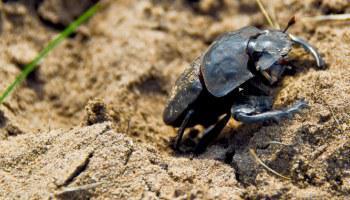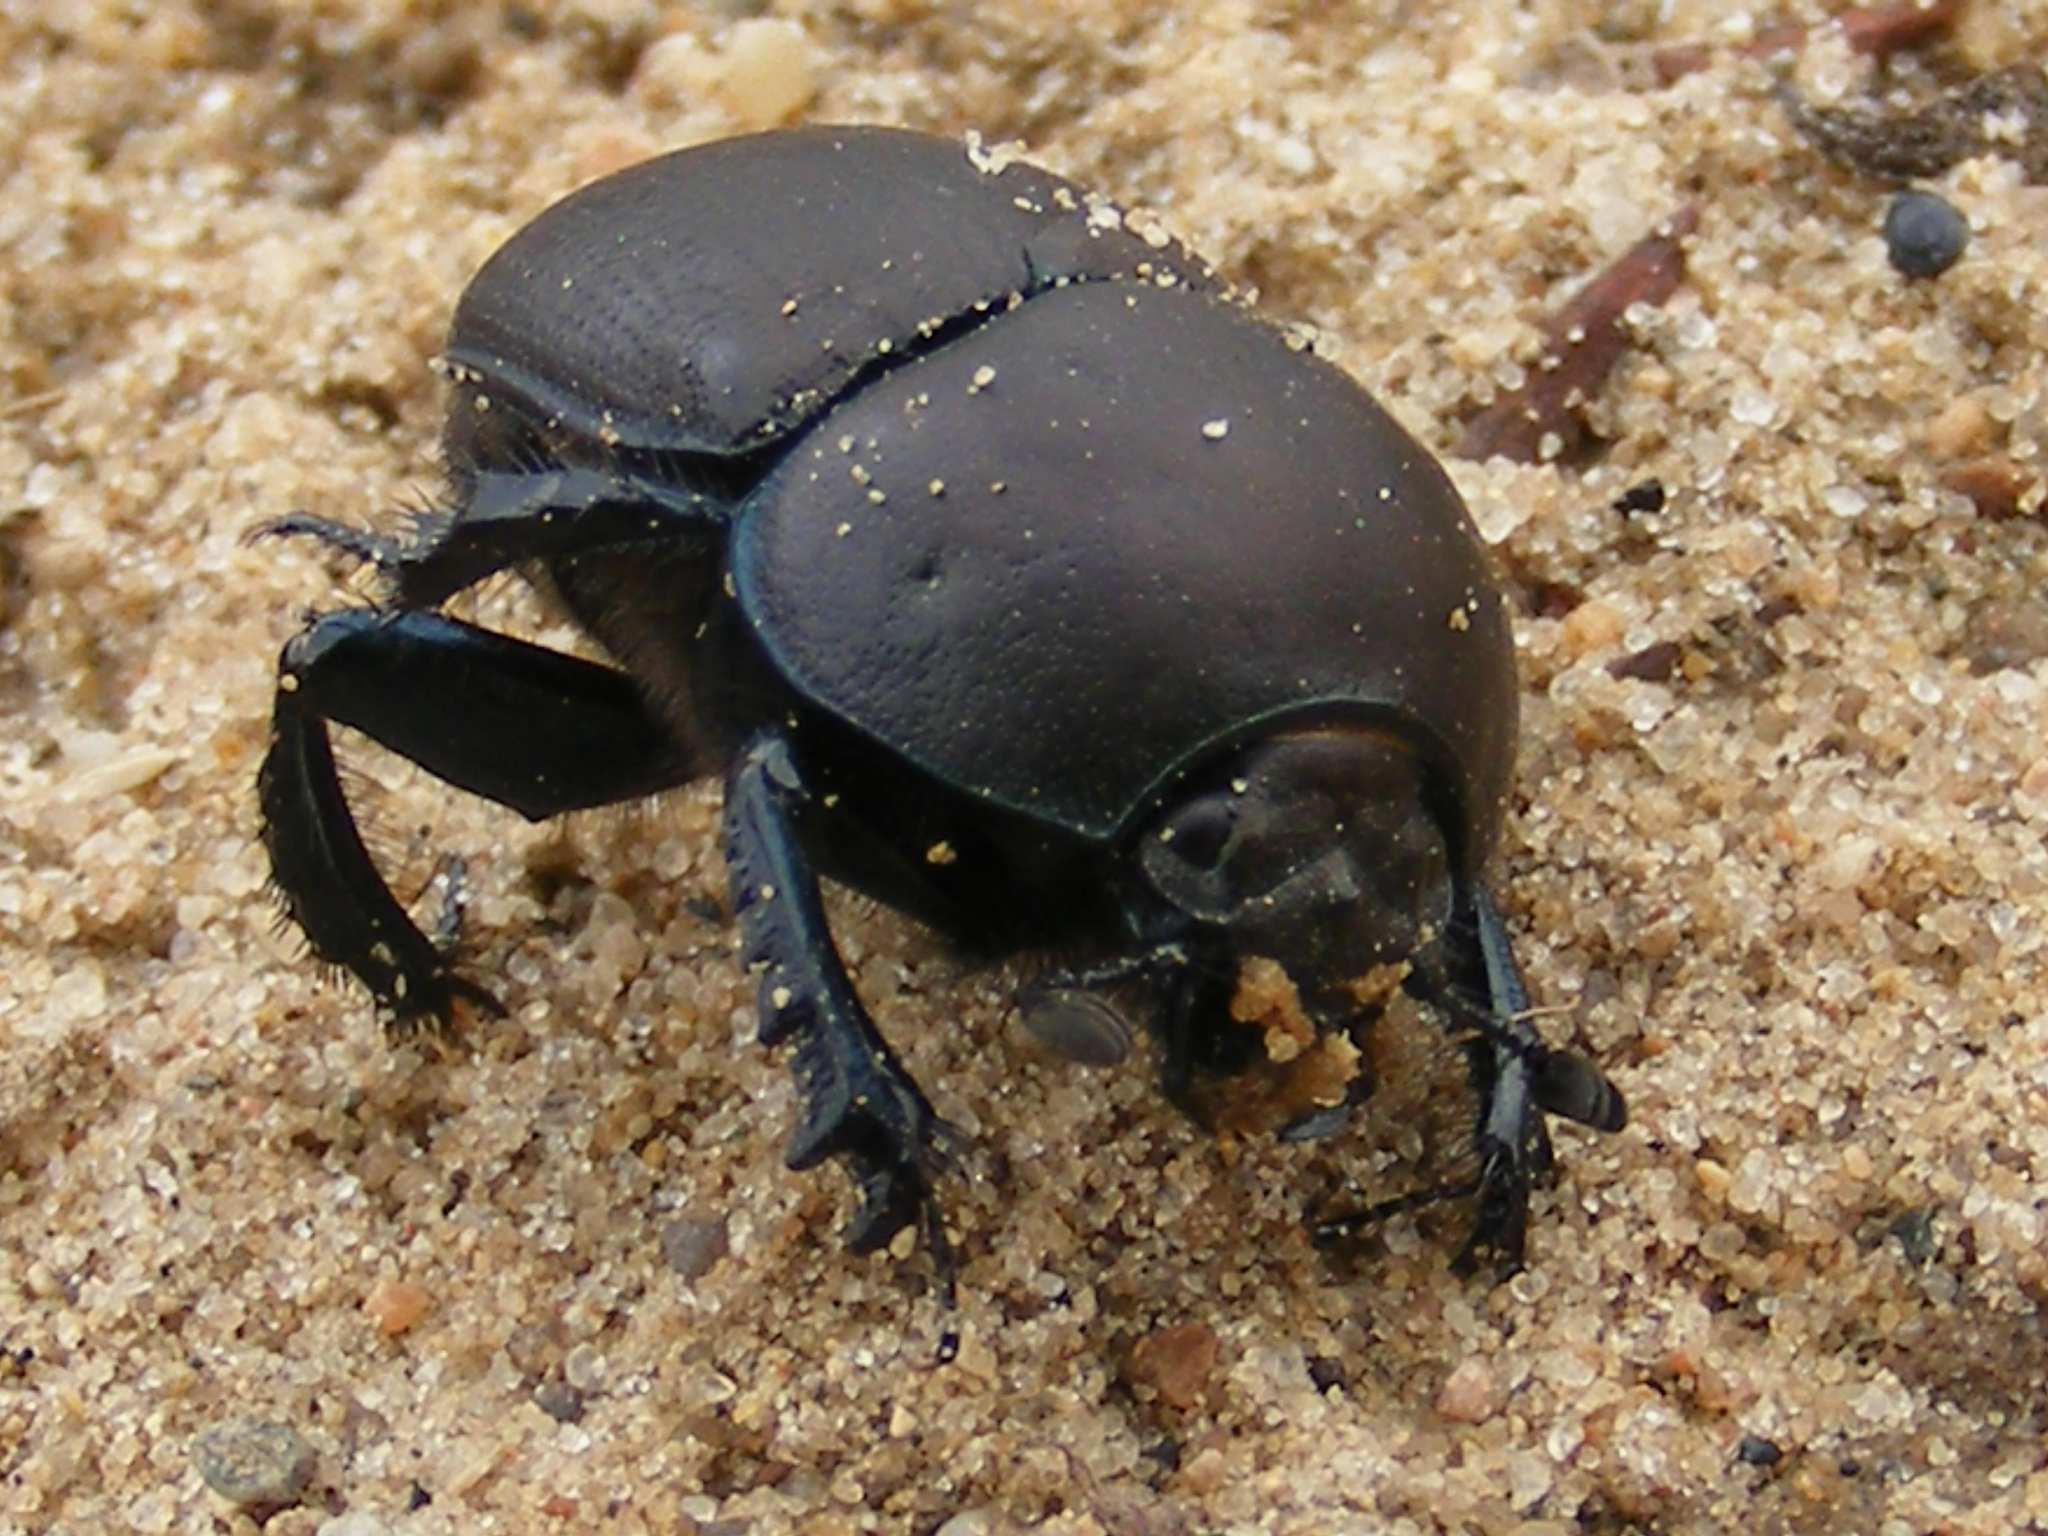The first image is the image on the left, the second image is the image on the right. For the images displayed, is the sentence "There are at most two scarab beetles." factually correct? Answer yes or no. Yes. 